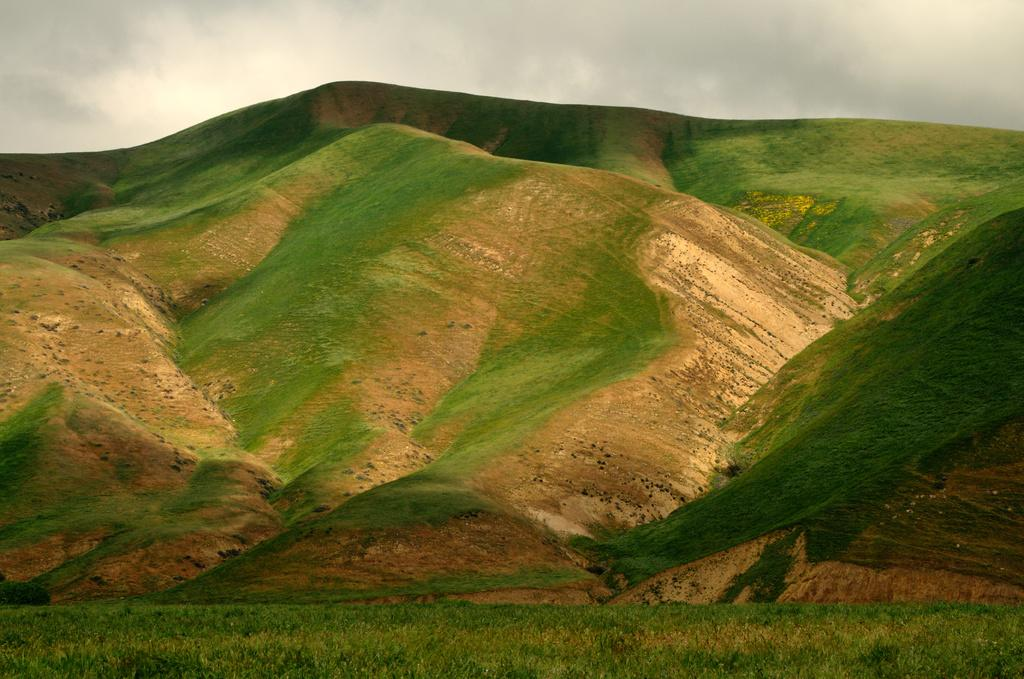What can be seen in the background of the image? The sky is visible in the background of the image. What type of landscape is depicted in the image? There are hills in the image, indicating a hilly landscape. What type of vegetation is present in the image? There is grass in the image, and the bottom portion of the image is full of greenery. What time of day is it in the image, based on the hour? The provided facts do not mention a specific time of day or hour, so it is not possible to determine the time based on the image. 